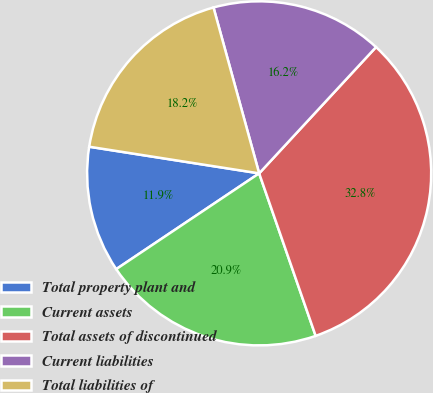Convert chart to OTSL. <chart><loc_0><loc_0><loc_500><loc_500><pie_chart><fcel>Total property plant and<fcel>Current assets<fcel>Total assets of discontinued<fcel>Current liabilities<fcel>Total liabilities of<nl><fcel>11.87%<fcel>20.93%<fcel>32.79%<fcel>16.16%<fcel>18.25%<nl></chart> 